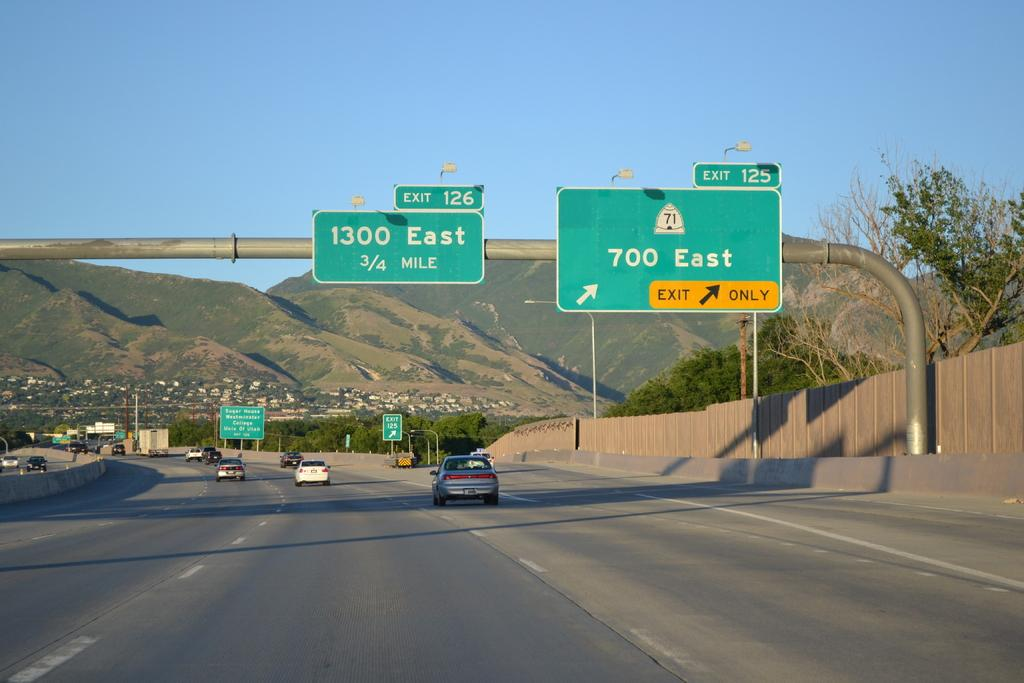<image>
Summarize the visual content of the image. a view of a highway with a sign reading 700 East. 